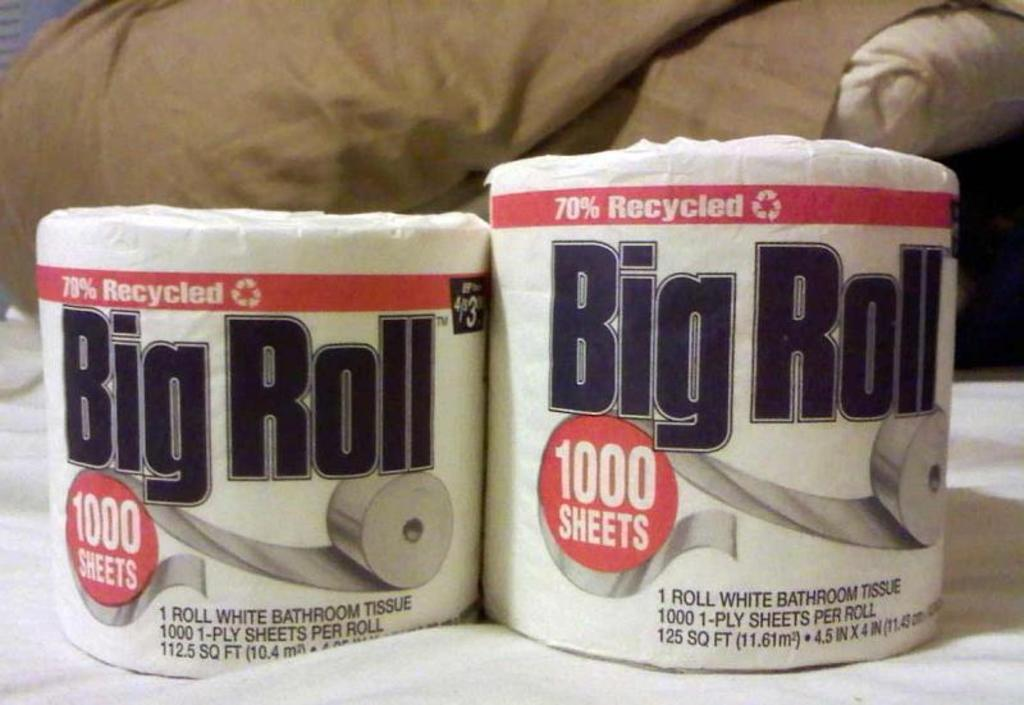How many tissue rolls are present in the image? There are two tissue rolls in the image. What can be found on the tissue rolls? There is text on the tissue rolls. What color is the surface visible in the image? The surface is white. What type of alarm can be heard going off in the image? There is no alarm present in the image, so no sound can be heard. 